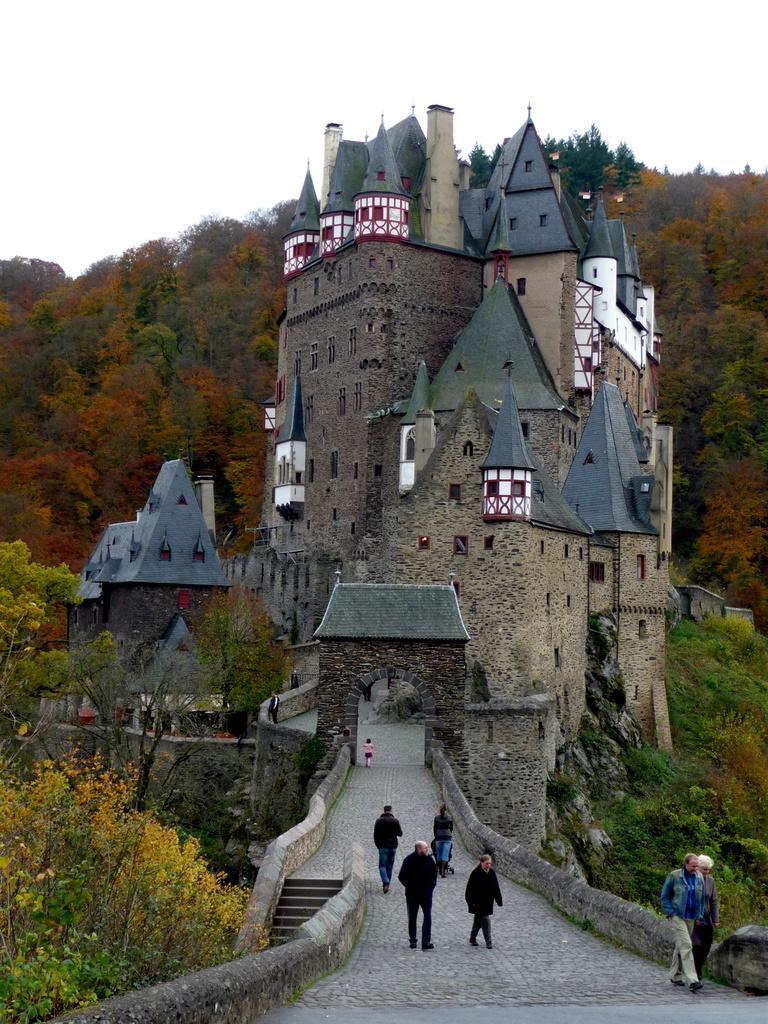In one or two sentences, can you explain what this image depicts? At the bottom, we see the road. On the right side, we see two people are walking. Beside that, we see a wall. Beside that, we see the trees. In the middle, we see the people are walking. Beside them, we see the staircase. On the left side, we see the trees. In the middle, we see an arch and a girl is standing. Behind the arch, we see the castles. There are trees in the background. At the top, we see the sky. 